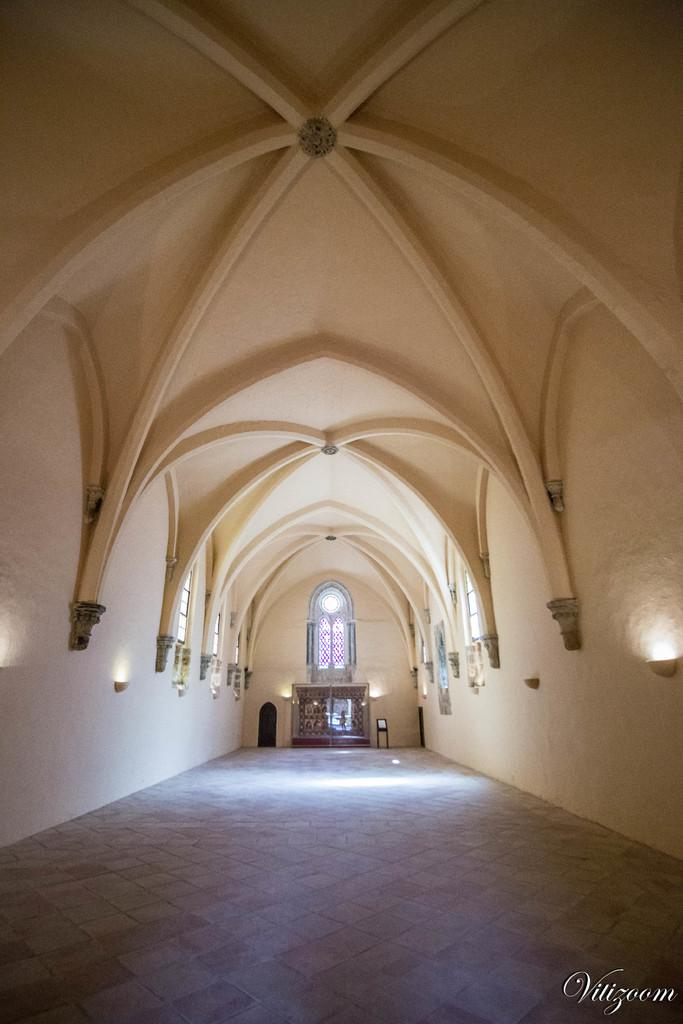What type of location is depicted in the image? The image is an inner view of a building. What architectural feature can be seen in the image? There is a wall in the image. What type of windows are present in the image? There are windows with stained glass in the image. What type of furniture is present in the image? There is a chair on the floor in the image. What type of lighting is present in the image? There are lights visible in the image. What is the uppermost part of the building in the image? There is a roof in the image. Where is the toothpaste located in the image? There is no toothpaste present in the image. 